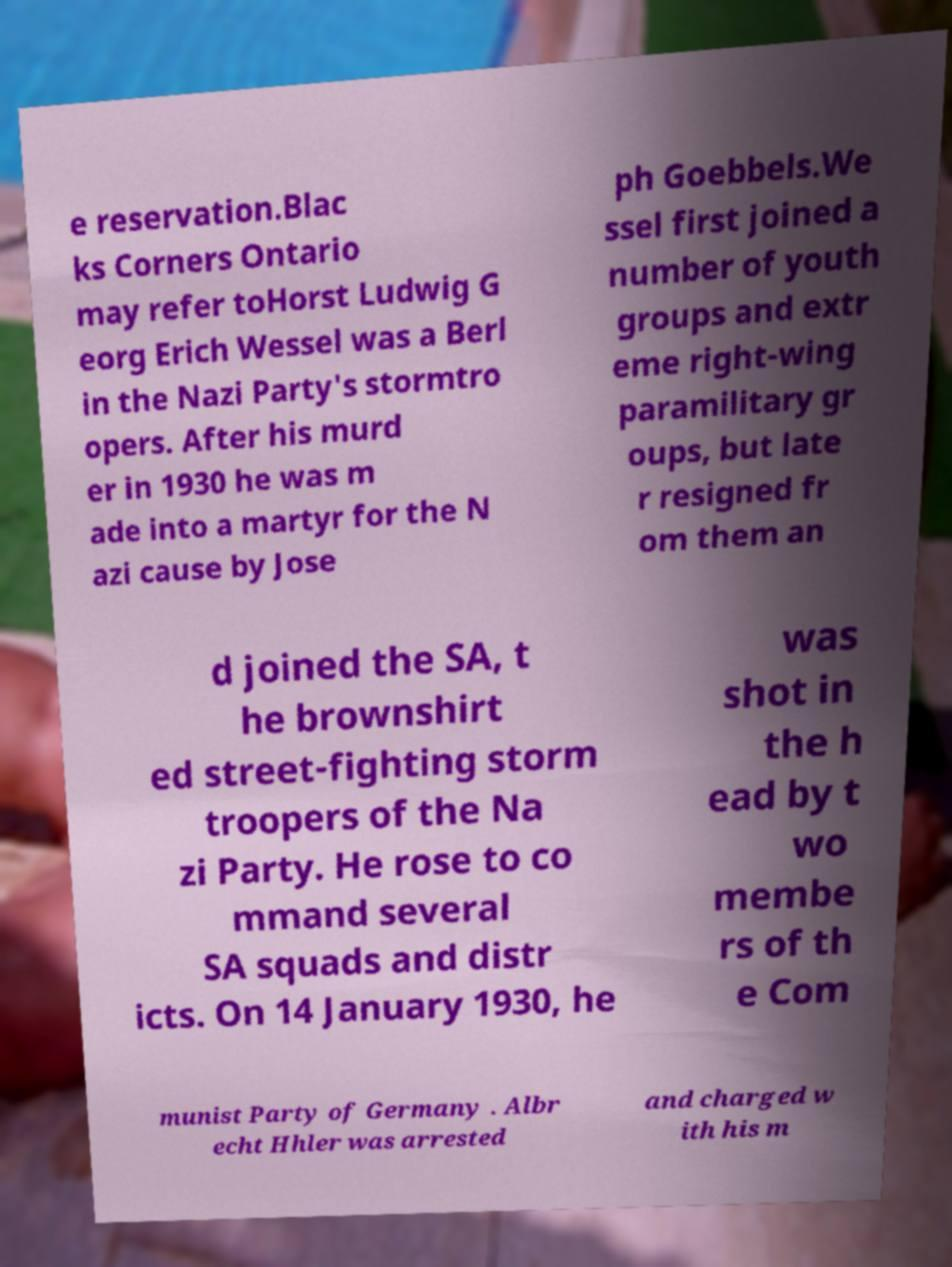What messages or text are displayed in this image? I need them in a readable, typed format. e reservation.Blac ks Corners Ontario may refer toHorst Ludwig G eorg Erich Wessel was a Berl in the Nazi Party's stormtro opers. After his murd er in 1930 he was m ade into a martyr for the N azi cause by Jose ph Goebbels.We ssel first joined a number of youth groups and extr eme right-wing paramilitary gr oups, but late r resigned fr om them an d joined the SA, t he brownshirt ed street-fighting storm troopers of the Na zi Party. He rose to co mmand several SA squads and distr icts. On 14 January 1930, he was shot in the h ead by t wo membe rs of th e Com munist Party of Germany . Albr echt Hhler was arrested and charged w ith his m 